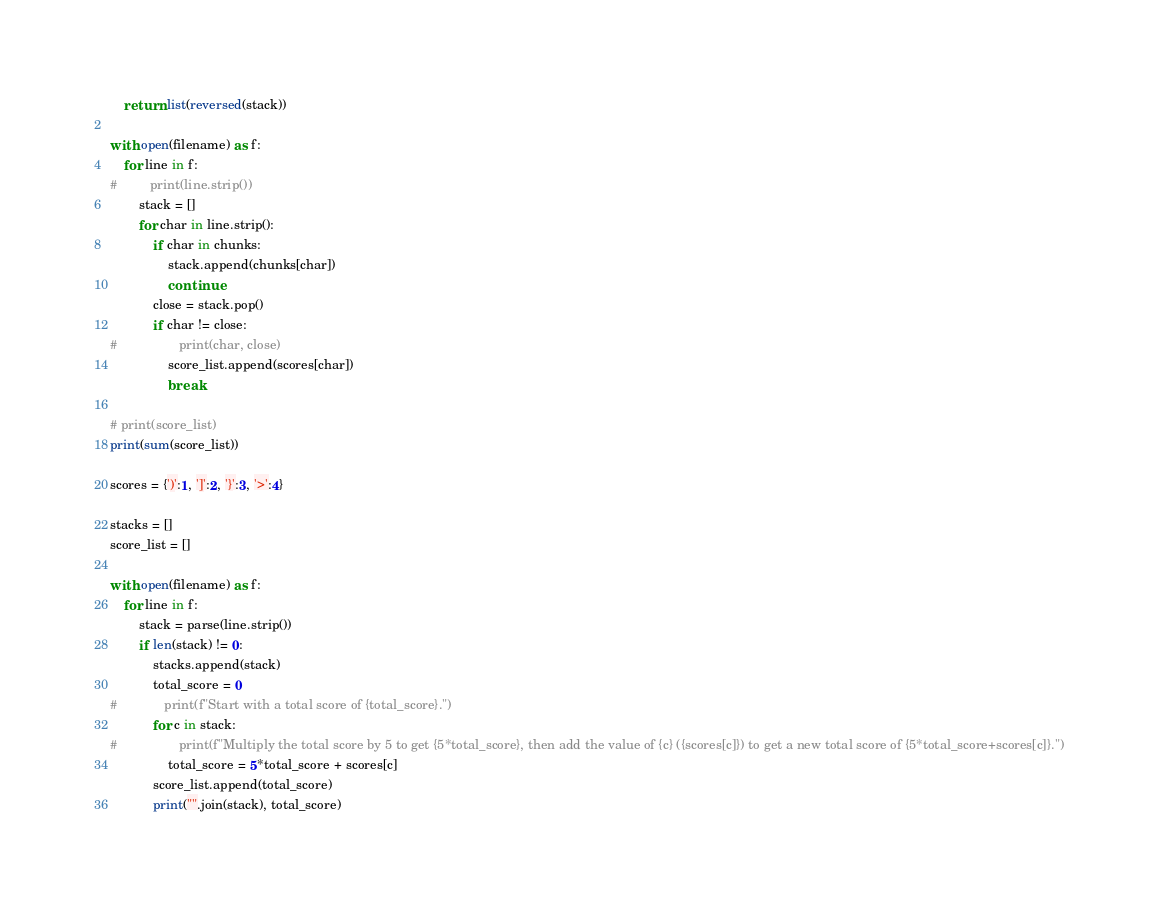Convert code to text. <code><loc_0><loc_0><loc_500><loc_500><_Python_>    return list(reversed(stack))

with open(filename) as f:
    for line in f:
#         print(line.strip())
        stack = []
        for char in line.strip():
            if char in chunks:
                stack.append(chunks[char])
                continue
            close = stack.pop()             
            if char != close:
#                 print(char, close)
                score_list.append(scores[char])
                break

# print(score_list)
print(sum(score_list))

scores = {')':1, ']':2, '}':3, '>':4}

stacks = []
score_list = []

with open(filename) as f:
    for line in f:
        stack = parse(line.strip())
        if len(stack) != 0:
            stacks.append(stack)
            total_score = 0
#             print(f"Start with a total score of {total_score}.")
            for c in stack:
#                 print(f"Multiply the total score by 5 to get {5*total_score}, then add the value of {c} ({scores[c]}) to get a new total score of {5*total_score+scores[c]}.")
                total_score = 5*total_score + scores[c]
            score_list.append(total_score)
            print("".join(stack), total_score)
</code> 